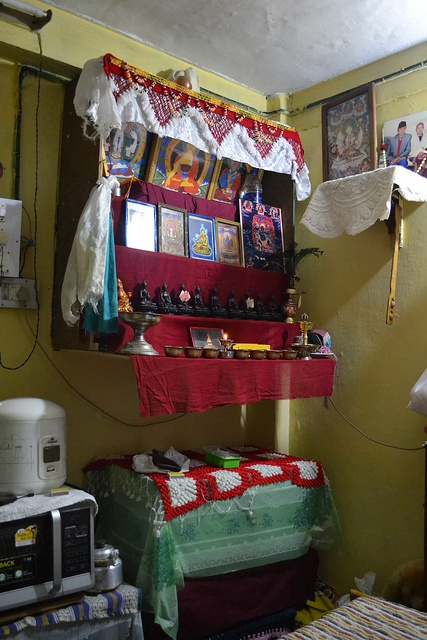Describe the objects in this image and their specific colors. I can see a microwave in gray, black, and olive tones in this image. 